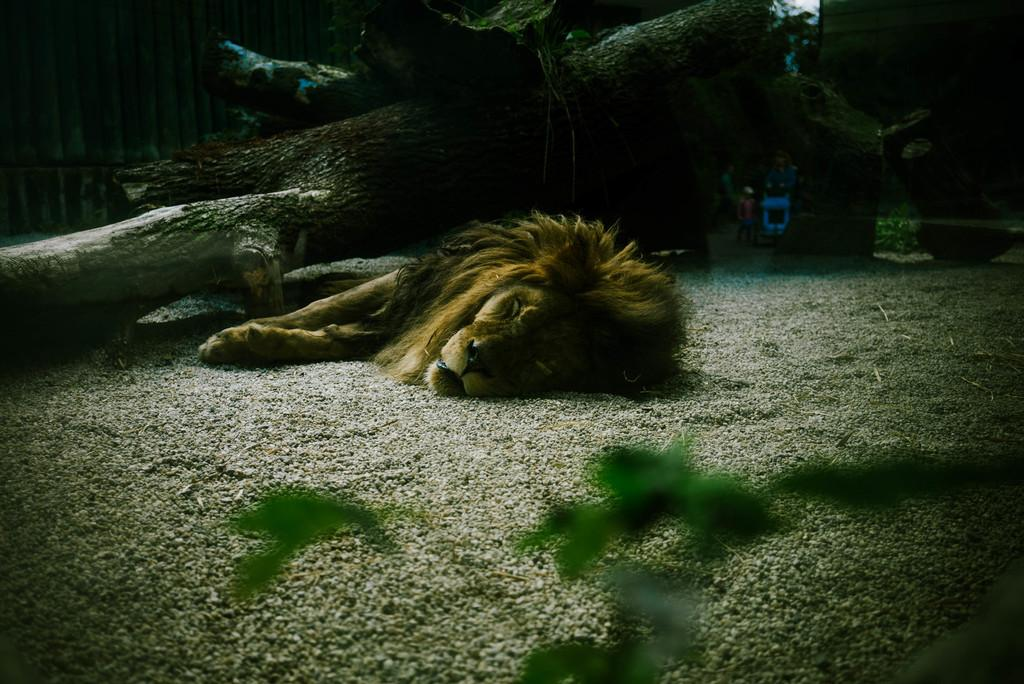What animal is the main subject of the image? There is a lion in the image. What is the lion doing in the image? The lion is sleeping on the ground. What can be seen behind the lion in the image? There are wooden logs behind the lion. How many oranges are being used as a suggestion for a science experiment in the image? There are no oranges, suggestions, or science experiments present in the image. 